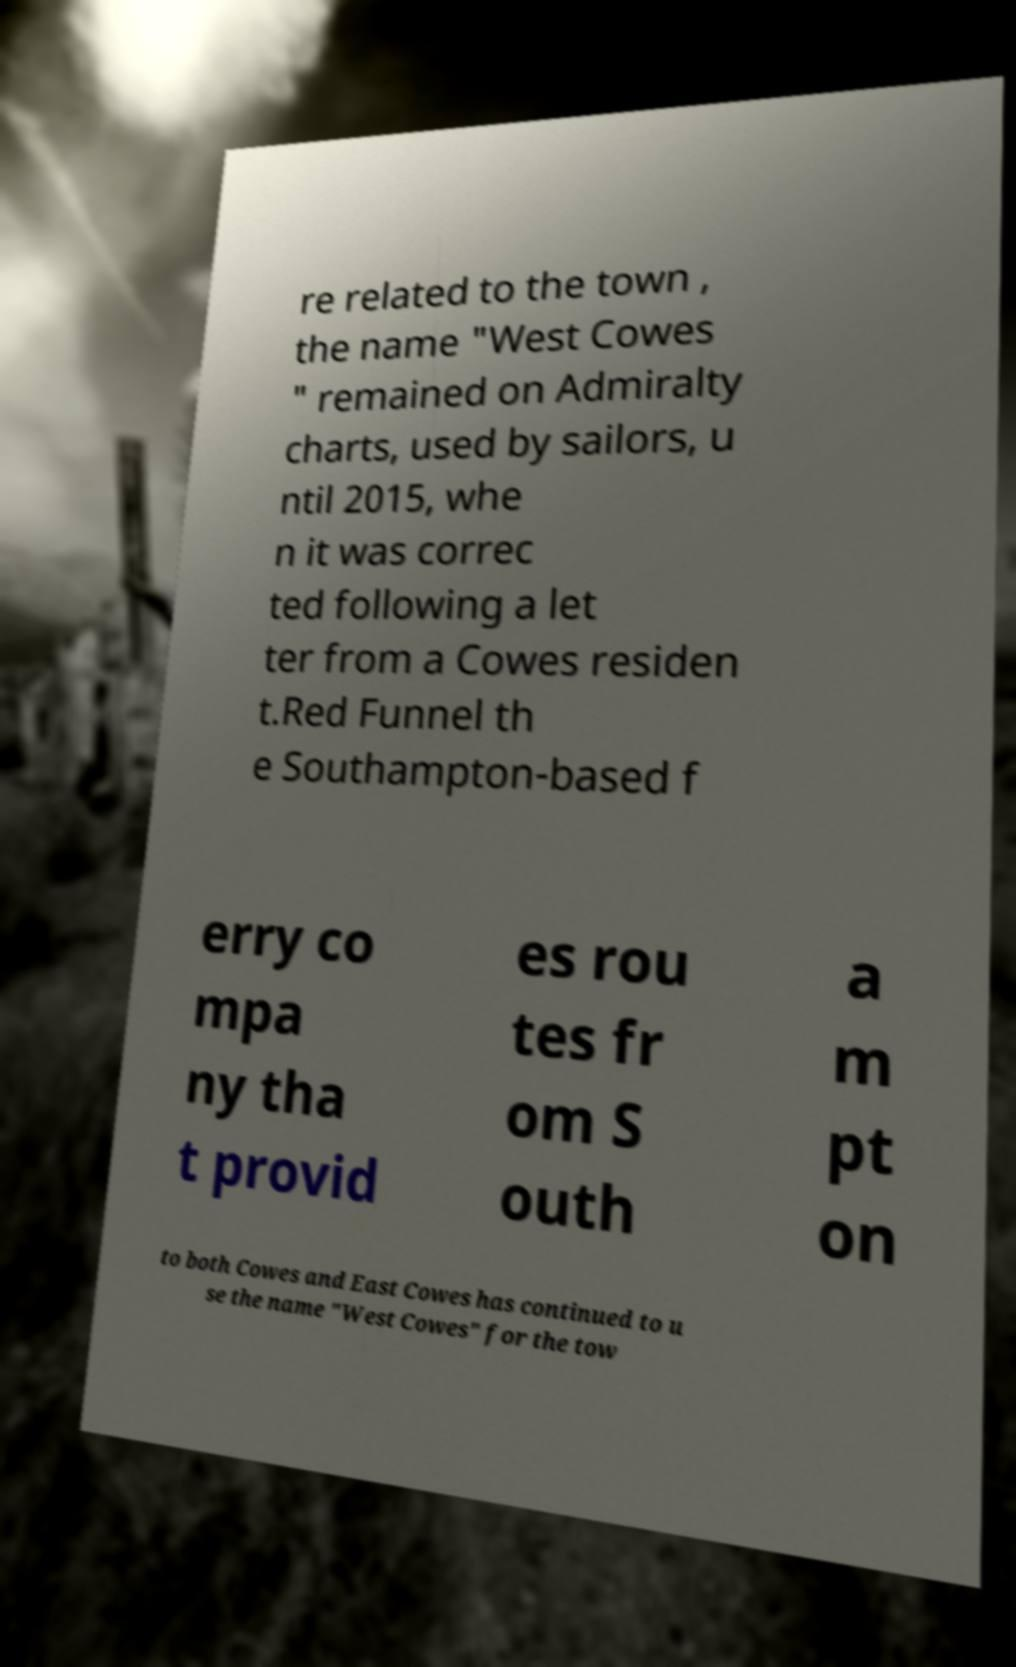There's text embedded in this image that I need extracted. Can you transcribe it verbatim? re related to the town , the name "West Cowes " remained on Admiralty charts, used by sailors, u ntil 2015, whe n it was correc ted following a let ter from a Cowes residen t.Red Funnel th e Southampton-based f erry co mpa ny tha t provid es rou tes fr om S outh a m pt on to both Cowes and East Cowes has continued to u se the name "West Cowes" for the tow 